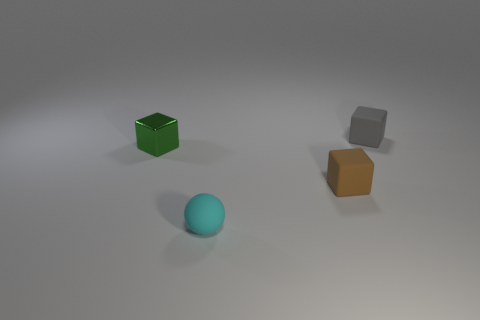What is the color of the tiny rubber cube in front of the small thing behind the tiny green cube?
Make the answer very short. Brown. Are there the same number of gray rubber objects that are to the right of the metal cube and green metal balls?
Provide a short and direct response. No. There is a small object in front of the cube that is in front of the shiny object; how many rubber objects are behind it?
Offer a very short reply. 2. What is the color of the matte block to the left of the gray cube?
Ensure brevity in your answer.  Brown. The object that is both in front of the green metal thing and left of the small brown rubber block is made of what material?
Your answer should be very brief. Rubber. How many green cubes are left of the matte block that is in front of the tiny gray block?
Your answer should be compact. 1. There is a tiny green object; what shape is it?
Offer a very short reply. Cube. What is the shape of the small cyan object that is made of the same material as the tiny brown block?
Provide a succinct answer. Sphere. There is a small rubber thing behind the metal thing; is it the same shape as the brown thing?
Offer a terse response. Yes. The cyan object in front of the tiny green shiny block has what shape?
Keep it short and to the point. Sphere. 